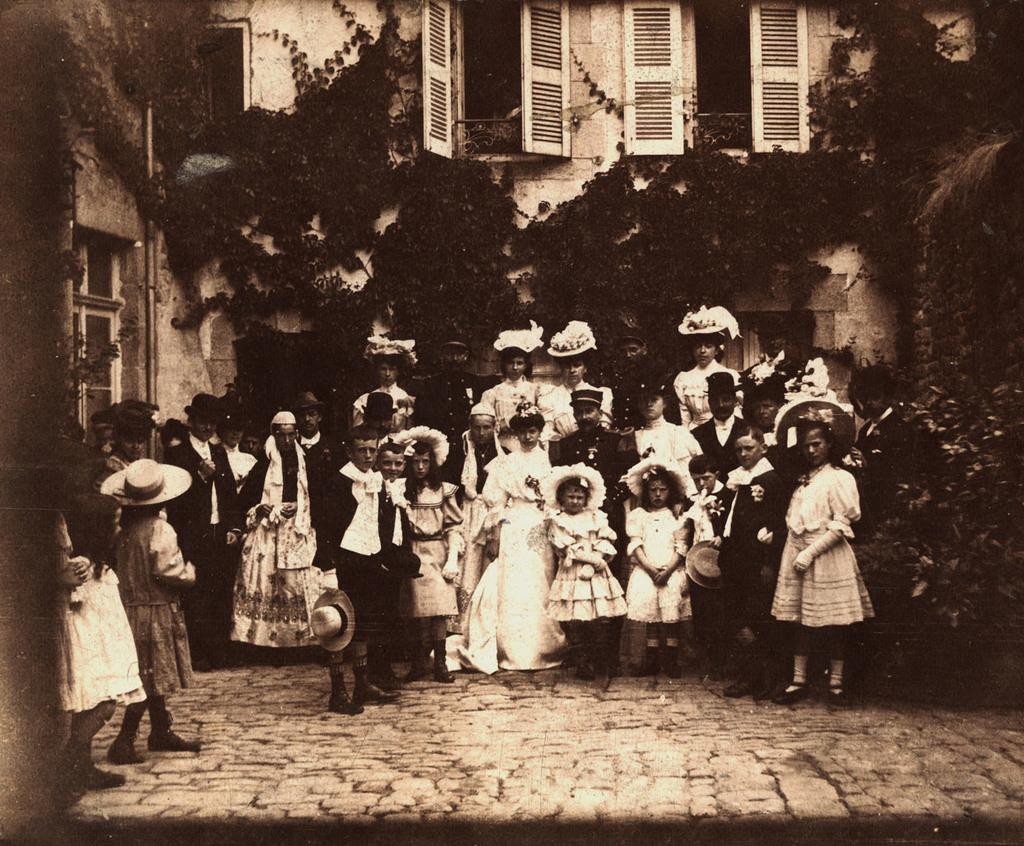What is the main subject in the foreground of the image? There is a crowd in the foreground of the image. Where is the crowd located? on the road? What can be seen in the background of the image? There are trees, creepers, a pipe, and a building in the background of the image. What features are visible on the building? Windows are visible on the building. How close is the image taken to the building? The image is taken near the building. How many yaks can be seen laughing and slipping in the image? There are no yaks present in the image, nor are there any instances of laughter or slipping. 